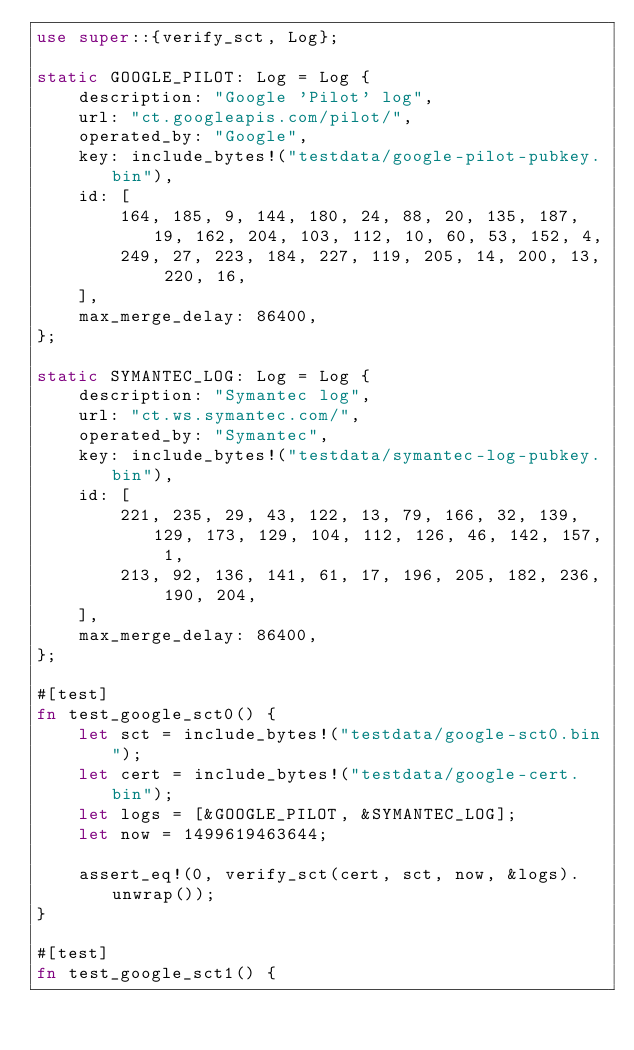<code> <loc_0><loc_0><loc_500><loc_500><_Rust_>use super::{verify_sct, Log};

static GOOGLE_PILOT: Log = Log {
    description: "Google 'Pilot' log",
    url: "ct.googleapis.com/pilot/",
    operated_by: "Google",
    key: include_bytes!("testdata/google-pilot-pubkey.bin"),
    id: [
        164, 185, 9, 144, 180, 24, 88, 20, 135, 187, 19, 162, 204, 103, 112, 10, 60, 53, 152, 4,
        249, 27, 223, 184, 227, 119, 205, 14, 200, 13, 220, 16,
    ],
    max_merge_delay: 86400,
};

static SYMANTEC_LOG: Log = Log {
    description: "Symantec log",
    url: "ct.ws.symantec.com/",
    operated_by: "Symantec",
    key: include_bytes!("testdata/symantec-log-pubkey.bin"),
    id: [
        221, 235, 29, 43, 122, 13, 79, 166, 32, 139, 129, 173, 129, 104, 112, 126, 46, 142, 157, 1,
        213, 92, 136, 141, 61, 17, 196, 205, 182, 236, 190, 204,
    ],
    max_merge_delay: 86400,
};

#[test]
fn test_google_sct0() {
    let sct = include_bytes!("testdata/google-sct0.bin");
    let cert = include_bytes!("testdata/google-cert.bin");
    let logs = [&GOOGLE_PILOT, &SYMANTEC_LOG];
    let now = 1499619463644;

    assert_eq!(0, verify_sct(cert, sct, now, &logs).unwrap());
}

#[test]
fn test_google_sct1() {</code> 